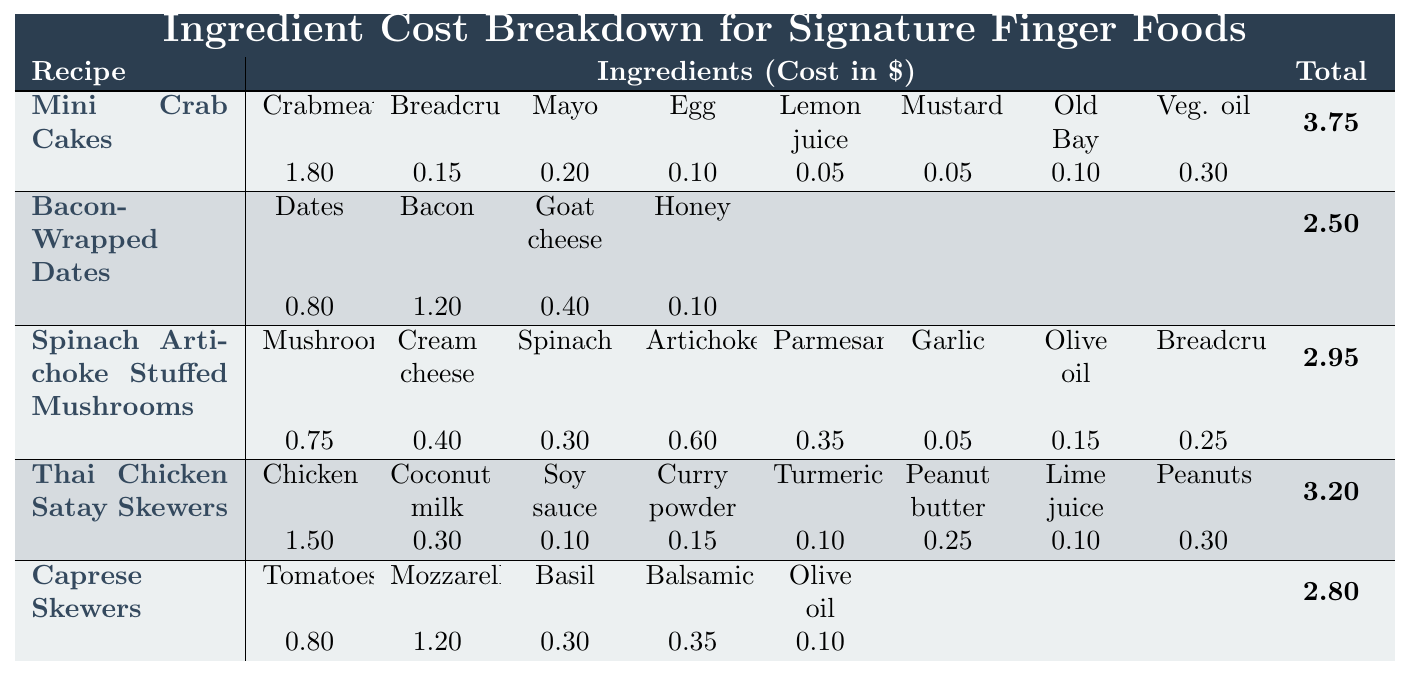What is the total cost per serving for Mini Crab Cakes? Referring to the table, the total cost per serving for Mini Crab Cakes is listed in the last column under the recipe name. The value is 3.75.
Answer: 3.75 How much do the ingredients for Bacon-Wrapped Dates cost in total? The individual ingredient costs for Bacon-Wrapped Dates are 0.80 (dates) + 1.20 (bacon) + 0.40 (goat cheese) + 0.10 (honey) = 2.50. Since this sum matches the total cost per serving, it confirms the total is right.
Answer: 2.50 Which recipe has the highest individual ingredient cost? The ingredient costs for each recipe should be compared. The most expensive ingredient in the table is the bacon for Bacon-Wrapped Dates, costing 1.20.
Answer: Bacon-Wrapped Dates What is the average ingredient cost per serving for all recipes listed? The total costs for each recipe are summed: 3.75 + 2.50 + 2.95 + 3.20 + 2.80 = 15.20. There are 5 recipes, so the average is 15.20 / 5 = 3.04.
Answer: 3.04 Does the recipe for Spinach Artichoke Stuffed Mushrooms contain garlic? Looking at the ingredients listed for Spinach Artichoke Stuffed Mushrooms, garlic is indeed one of the ingredients.
Answer: Yes Which recipe is the least expensive per serving? By reviewing the total cost per serving for each recipe, Bacon-Wrapped Dates has the lowest cost at 2.50.
Answer: Bacon-Wrapped Dates What is the difference between the total cost per serving of Mini Crab Cakes and Thai Chicken Satay Skewers? The difference is calculated by subtracting the total of Thai Chicken Satay Skewers (3.20) from Mini Crab Cakes (3.75): 3.75 - 3.20 = 0.55.
Answer: 0.55 How much does the combined cost of the ingredients for Caprese Skewers exceed the cost of its serving? The cost of ingredients totals: 0.80 (tomatoes) + 1.20 (mozzarella) + 0.30 (basil) + 0.35 (balsamic) + 0.10 (olive oil) = 2.75. The serving cost is 2.80, so the difference is 2.75 - 2.80 = -0.05, meaning it is less expensive by 0.05.
Answer: -0.05 What is the cost of the cheapest ingredient in the recipe for Thai Chicken Satay Skewers? In the Thai Chicken Satay Skewers recipe, the garlic and ginger cost 0.05 each, making them the cheapest ingredients.
Answer: 0.05 Is the total cost per serving for any recipe greater than 3.00? By checking all the total costs per serving, Mini Crab Cakes (3.75) and Thai Chicken Satay Skewers (3.20) both exceed 3.00.
Answer: Yes 